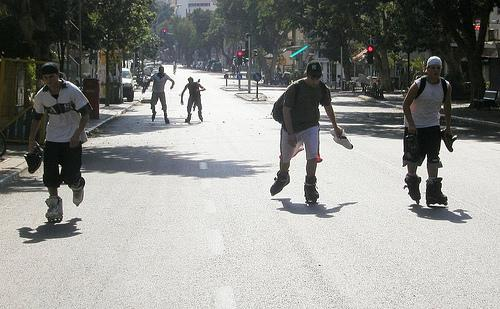What enables these people to go faster on the street? roller blades 